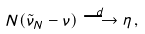<formula> <loc_0><loc_0><loc_500><loc_500>N ( \tilde { \nu } _ { N } - \nu ) \overset { d } { \longrightarrow } \eta \, ,</formula> 